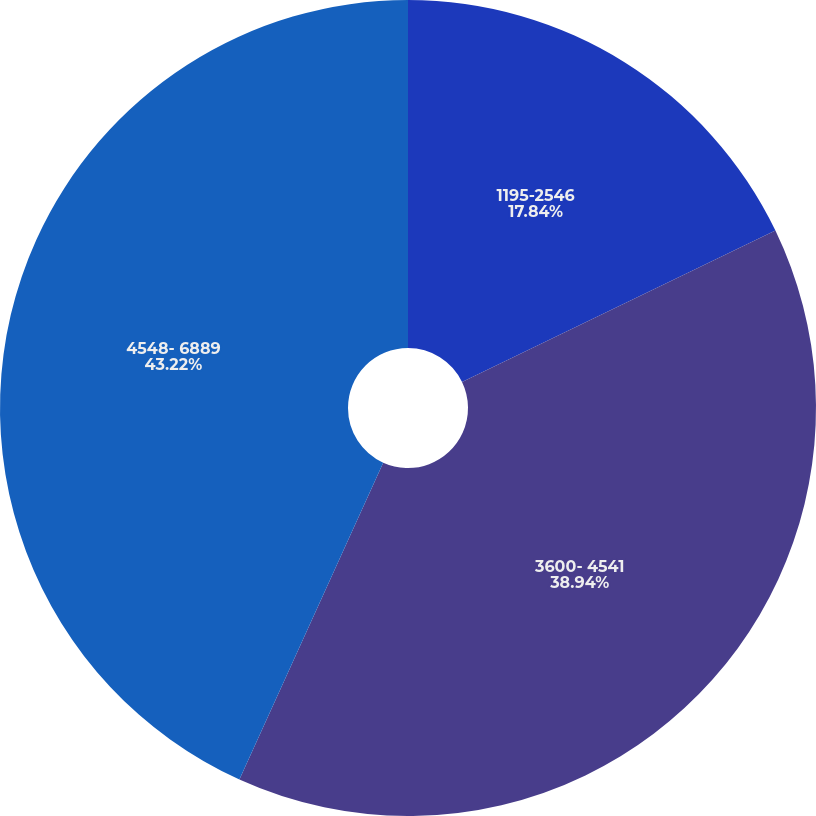<chart> <loc_0><loc_0><loc_500><loc_500><pie_chart><fcel>1195-2546<fcel>3600- 4541<fcel>4548- 6889<nl><fcel>17.84%<fcel>38.94%<fcel>43.22%<nl></chart> 